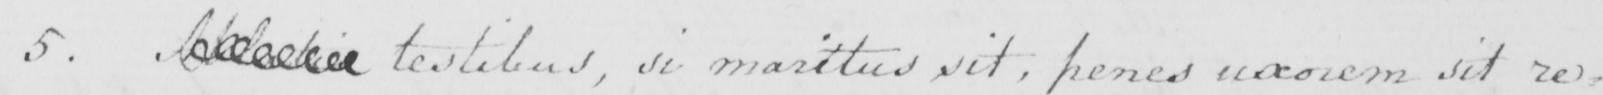What does this handwritten line say? 5 .  <gap/>   testibus , si maritus sit , penes uxorem it re= 